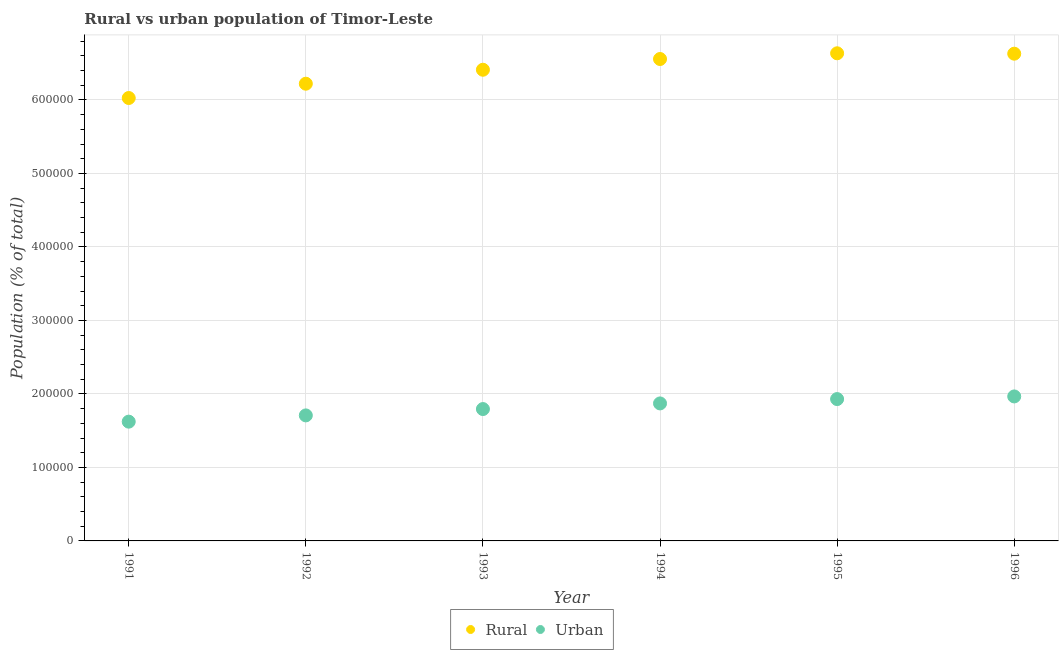How many different coloured dotlines are there?
Provide a succinct answer. 2. Is the number of dotlines equal to the number of legend labels?
Provide a succinct answer. Yes. What is the rural population density in 1994?
Offer a very short reply. 6.56e+05. Across all years, what is the maximum urban population density?
Provide a short and direct response. 1.97e+05. Across all years, what is the minimum rural population density?
Offer a terse response. 6.03e+05. In which year was the urban population density minimum?
Offer a very short reply. 1991. What is the total urban population density in the graph?
Keep it short and to the point. 1.09e+06. What is the difference between the rural population density in 1993 and that in 1996?
Keep it short and to the point. -2.18e+04. What is the difference between the rural population density in 1993 and the urban population density in 1995?
Your answer should be compact. 4.48e+05. What is the average urban population density per year?
Keep it short and to the point. 1.82e+05. In the year 1994, what is the difference between the urban population density and rural population density?
Offer a terse response. -4.69e+05. In how many years, is the urban population density greater than 520000 %?
Ensure brevity in your answer.  0. What is the ratio of the urban population density in 1994 to that in 1995?
Offer a very short reply. 0.97. Is the urban population density in 1991 less than that in 1993?
Give a very brief answer. Yes. What is the difference between the highest and the second highest rural population density?
Offer a very short reply. 546. What is the difference between the highest and the lowest urban population density?
Offer a terse response. 3.43e+04. Does the urban population density monotonically increase over the years?
Provide a short and direct response. Yes. Does the graph contain any zero values?
Make the answer very short. No. Does the graph contain grids?
Provide a short and direct response. Yes. Where does the legend appear in the graph?
Offer a terse response. Bottom center. How are the legend labels stacked?
Provide a succinct answer. Horizontal. What is the title of the graph?
Provide a short and direct response. Rural vs urban population of Timor-Leste. Does "Time to import" appear as one of the legend labels in the graph?
Keep it short and to the point. No. What is the label or title of the X-axis?
Provide a succinct answer. Year. What is the label or title of the Y-axis?
Your answer should be very brief. Population (% of total). What is the Population (% of total) in Rural in 1991?
Ensure brevity in your answer.  6.03e+05. What is the Population (% of total) of Urban in 1991?
Your answer should be compact. 1.62e+05. What is the Population (% of total) in Rural in 1992?
Your response must be concise. 6.22e+05. What is the Population (% of total) in Urban in 1992?
Keep it short and to the point. 1.71e+05. What is the Population (% of total) in Rural in 1993?
Your answer should be compact. 6.41e+05. What is the Population (% of total) in Urban in 1993?
Your response must be concise. 1.79e+05. What is the Population (% of total) in Rural in 1994?
Keep it short and to the point. 6.56e+05. What is the Population (% of total) of Urban in 1994?
Make the answer very short. 1.87e+05. What is the Population (% of total) in Rural in 1995?
Your answer should be compact. 6.63e+05. What is the Population (% of total) of Urban in 1995?
Offer a very short reply. 1.93e+05. What is the Population (% of total) of Rural in 1996?
Your response must be concise. 6.63e+05. What is the Population (% of total) of Urban in 1996?
Make the answer very short. 1.97e+05. Across all years, what is the maximum Population (% of total) of Rural?
Give a very brief answer. 6.63e+05. Across all years, what is the maximum Population (% of total) in Urban?
Ensure brevity in your answer.  1.97e+05. Across all years, what is the minimum Population (% of total) in Rural?
Ensure brevity in your answer.  6.03e+05. Across all years, what is the minimum Population (% of total) of Urban?
Offer a terse response. 1.62e+05. What is the total Population (% of total) of Rural in the graph?
Keep it short and to the point. 3.85e+06. What is the total Population (% of total) of Urban in the graph?
Provide a succinct answer. 1.09e+06. What is the difference between the Population (% of total) of Rural in 1991 and that in 1992?
Your answer should be compact. -1.95e+04. What is the difference between the Population (% of total) of Urban in 1991 and that in 1992?
Offer a terse response. -8509. What is the difference between the Population (% of total) of Rural in 1991 and that in 1993?
Make the answer very short. -3.84e+04. What is the difference between the Population (% of total) of Urban in 1991 and that in 1993?
Your response must be concise. -1.71e+04. What is the difference between the Population (% of total) in Rural in 1991 and that in 1994?
Provide a short and direct response. -5.31e+04. What is the difference between the Population (% of total) in Urban in 1991 and that in 1994?
Provide a succinct answer. -2.48e+04. What is the difference between the Population (% of total) in Rural in 1991 and that in 1995?
Provide a short and direct response. -6.08e+04. What is the difference between the Population (% of total) in Urban in 1991 and that in 1995?
Ensure brevity in your answer.  -3.07e+04. What is the difference between the Population (% of total) of Rural in 1991 and that in 1996?
Offer a terse response. -6.03e+04. What is the difference between the Population (% of total) in Urban in 1991 and that in 1996?
Ensure brevity in your answer.  -3.43e+04. What is the difference between the Population (% of total) in Rural in 1992 and that in 1993?
Your answer should be very brief. -1.90e+04. What is the difference between the Population (% of total) of Urban in 1992 and that in 1993?
Your answer should be compact. -8633. What is the difference between the Population (% of total) in Rural in 1992 and that in 1994?
Your answer should be compact. -3.36e+04. What is the difference between the Population (% of total) in Urban in 1992 and that in 1994?
Make the answer very short. -1.63e+04. What is the difference between the Population (% of total) of Rural in 1992 and that in 1995?
Make the answer very short. -4.14e+04. What is the difference between the Population (% of total) in Urban in 1992 and that in 1995?
Make the answer very short. -2.22e+04. What is the difference between the Population (% of total) in Rural in 1992 and that in 1996?
Offer a very short reply. -4.08e+04. What is the difference between the Population (% of total) in Urban in 1992 and that in 1996?
Give a very brief answer. -2.58e+04. What is the difference between the Population (% of total) in Rural in 1993 and that in 1994?
Offer a very short reply. -1.46e+04. What is the difference between the Population (% of total) of Urban in 1993 and that in 1994?
Give a very brief answer. -7671. What is the difference between the Population (% of total) of Rural in 1993 and that in 1995?
Your answer should be compact. -2.24e+04. What is the difference between the Population (% of total) in Urban in 1993 and that in 1995?
Your response must be concise. -1.36e+04. What is the difference between the Population (% of total) in Rural in 1993 and that in 1996?
Offer a very short reply. -2.18e+04. What is the difference between the Population (% of total) of Urban in 1993 and that in 1996?
Provide a succinct answer. -1.72e+04. What is the difference between the Population (% of total) in Rural in 1994 and that in 1995?
Your response must be concise. -7780. What is the difference between the Population (% of total) of Urban in 1994 and that in 1995?
Your answer should be very brief. -5907. What is the difference between the Population (% of total) of Rural in 1994 and that in 1996?
Provide a short and direct response. -7234. What is the difference between the Population (% of total) of Urban in 1994 and that in 1996?
Offer a terse response. -9510. What is the difference between the Population (% of total) of Rural in 1995 and that in 1996?
Keep it short and to the point. 546. What is the difference between the Population (% of total) of Urban in 1995 and that in 1996?
Keep it short and to the point. -3603. What is the difference between the Population (% of total) of Rural in 1991 and the Population (% of total) of Urban in 1992?
Offer a terse response. 4.32e+05. What is the difference between the Population (% of total) of Rural in 1991 and the Population (% of total) of Urban in 1993?
Provide a succinct answer. 4.23e+05. What is the difference between the Population (% of total) of Rural in 1991 and the Population (% of total) of Urban in 1994?
Make the answer very short. 4.16e+05. What is the difference between the Population (% of total) in Rural in 1991 and the Population (% of total) in Urban in 1995?
Your answer should be compact. 4.10e+05. What is the difference between the Population (% of total) in Rural in 1991 and the Population (% of total) in Urban in 1996?
Your answer should be very brief. 4.06e+05. What is the difference between the Population (% of total) in Rural in 1992 and the Population (% of total) in Urban in 1993?
Your answer should be very brief. 4.43e+05. What is the difference between the Population (% of total) in Rural in 1992 and the Population (% of total) in Urban in 1994?
Make the answer very short. 4.35e+05. What is the difference between the Population (% of total) of Rural in 1992 and the Population (% of total) of Urban in 1995?
Keep it short and to the point. 4.29e+05. What is the difference between the Population (% of total) of Rural in 1992 and the Population (% of total) of Urban in 1996?
Offer a very short reply. 4.25e+05. What is the difference between the Population (% of total) of Rural in 1993 and the Population (% of total) of Urban in 1994?
Your response must be concise. 4.54e+05. What is the difference between the Population (% of total) of Rural in 1993 and the Population (% of total) of Urban in 1995?
Provide a short and direct response. 4.48e+05. What is the difference between the Population (% of total) in Rural in 1993 and the Population (% of total) in Urban in 1996?
Keep it short and to the point. 4.44e+05. What is the difference between the Population (% of total) in Rural in 1994 and the Population (% of total) in Urban in 1995?
Make the answer very short. 4.63e+05. What is the difference between the Population (% of total) in Rural in 1994 and the Population (% of total) in Urban in 1996?
Your answer should be very brief. 4.59e+05. What is the difference between the Population (% of total) of Rural in 1995 and the Population (% of total) of Urban in 1996?
Offer a very short reply. 4.67e+05. What is the average Population (% of total) in Rural per year?
Your answer should be very brief. 6.41e+05. What is the average Population (% of total) of Urban per year?
Your answer should be very brief. 1.82e+05. In the year 1991, what is the difference between the Population (% of total) of Rural and Population (% of total) of Urban?
Offer a terse response. 4.40e+05. In the year 1992, what is the difference between the Population (% of total) of Rural and Population (% of total) of Urban?
Give a very brief answer. 4.51e+05. In the year 1993, what is the difference between the Population (% of total) of Rural and Population (% of total) of Urban?
Ensure brevity in your answer.  4.62e+05. In the year 1994, what is the difference between the Population (% of total) in Rural and Population (% of total) in Urban?
Make the answer very short. 4.69e+05. In the year 1995, what is the difference between the Population (% of total) in Rural and Population (% of total) in Urban?
Make the answer very short. 4.70e+05. In the year 1996, what is the difference between the Population (% of total) in Rural and Population (% of total) in Urban?
Give a very brief answer. 4.66e+05. What is the ratio of the Population (% of total) in Rural in 1991 to that in 1992?
Give a very brief answer. 0.97. What is the ratio of the Population (% of total) in Urban in 1991 to that in 1992?
Give a very brief answer. 0.95. What is the ratio of the Population (% of total) of Rural in 1991 to that in 1993?
Your answer should be very brief. 0.94. What is the ratio of the Population (% of total) in Urban in 1991 to that in 1993?
Provide a short and direct response. 0.9. What is the ratio of the Population (% of total) of Rural in 1991 to that in 1994?
Your answer should be very brief. 0.92. What is the ratio of the Population (% of total) of Urban in 1991 to that in 1994?
Provide a succinct answer. 0.87. What is the ratio of the Population (% of total) of Rural in 1991 to that in 1995?
Your answer should be very brief. 0.91. What is the ratio of the Population (% of total) of Urban in 1991 to that in 1995?
Offer a terse response. 0.84. What is the ratio of the Population (% of total) in Urban in 1991 to that in 1996?
Offer a very short reply. 0.83. What is the ratio of the Population (% of total) of Rural in 1992 to that in 1993?
Provide a short and direct response. 0.97. What is the ratio of the Population (% of total) of Urban in 1992 to that in 1993?
Give a very brief answer. 0.95. What is the ratio of the Population (% of total) of Rural in 1992 to that in 1994?
Make the answer very short. 0.95. What is the ratio of the Population (% of total) of Urban in 1992 to that in 1994?
Offer a very short reply. 0.91. What is the ratio of the Population (% of total) in Rural in 1992 to that in 1995?
Offer a terse response. 0.94. What is the ratio of the Population (% of total) of Urban in 1992 to that in 1995?
Ensure brevity in your answer.  0.88. What is the ratio of the Population (% of total) of Rural in 1992 to that in 1996?
Your response must be concise. 0.94. What is the ratio of the Population (% of total) of Urban in 1992 to that in 1996?
Your answer should be compact. 0.87. What is the ratio of the Population (% of total) of Rural in 1993 to that in 1994?
Your answer should be compact. 0.98. What is the ratio of the Population (% of total) in Urban in 1993 to that in 1994?
Your answer should be very brief. 0.96. What is the ratio of the Population (% of total) in Rural in 1993 to that in 1995?
Provide a succinct answer. 0.97. What is the ratio of the Population (% of total) of Urban in 1993 to that in 1995?
Your answer should be very brief. 0.93. What is the ratio of the Population (% of total) in Rural in 1993 to that in 1996?
Provide a succinct answer. 0.97. What is the ratio of the Population (% of total) in Urban in 1993 to that in 1996?
Provide a succinct answer. 0.91. What is the ratio of the Population (% of total) in Rural in 1994 to that in 1995?
Ensure brevity in your answer.  0.99. What is the ratio of the Population (% of total) in Urban in 1994 to that in 1995?
Your answer should be compact. 0.97. What is the ratio of the Population (% of total) in Rural in 1994 to that in 1996?
Provide a succinct answer. 0.99. What is the ratio of the Population (% of total) of Urban in 1994 to that in 1996?
Make the answer very short. 0.95. What is the ratio of the Population (% of total) in Urban in 1995 to that in 1996?
Your response must be concise. 0.98. What is the difference between the highest and the second highest Population (% of total) of Rural?
Provide a short and direct response. 546. What is the difference between the highest and the second highest Population (% of total) in Urban?
Give a very brief answer. 3603. What is the difference between the highest and the lowest Population (% of total) in Rural?
Ensure brevity in your answer.  6.08e+04. What is the difference between the highest and the lowest Population (% of total) of Urban?
Offer a very short reply. 3.43e+04. 